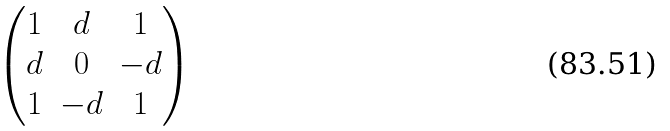<formula> <loc_0><loc_0><loc_500><loc_500>\begin{pmatrix} 1 & d & 1 \\ d & 0 & - d \\ 1 & - d & 1 \end{pmatrix}</formula> 